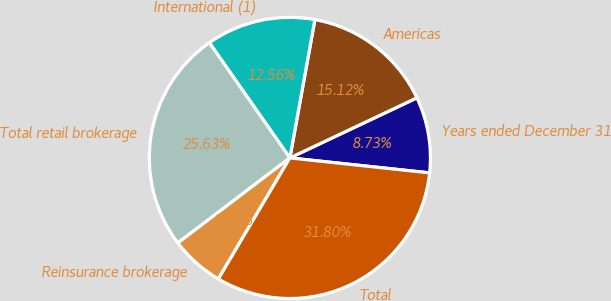<chart> <loc_0><loc_0><loc_500><loc_500><pie_chart><fcel>Years ended December 31<fcel>Americas<fcel>International (1)<fcel>Total retail brokerage<fcel>Reinsurance brokerage<fcel>Total<nl><fcel>8.73%<fcel>15.12%<fcel>12.56%<fcel>25.63%<fcel>6.17%<fcel>31.8%<nl></chart> 